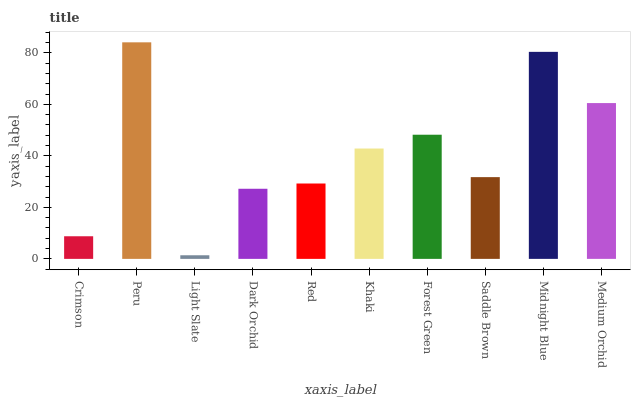Is Peru the minimum?
Answer yes or no. No. Is Light Slate the maximum?
Answer yes or no. No. Is Peru greater than Light Slate?
Answer yes or no. Yes. Is Light Slate less than Peru?
Answer yes or no. Yes. Is Light Slate greater than Peru?
Answer yes or no. No. Is Peru less than Light Slate?
Answer yes or no. No. Is Khaki the high median?
Answer yes or no. Yes. Is Saddle Brown the low median?
Answer yes or no. Yes. Is Dark Orchid the high median?
Answer yes or no. No. Is Khaki the low median?
Answer yes or no. No. 